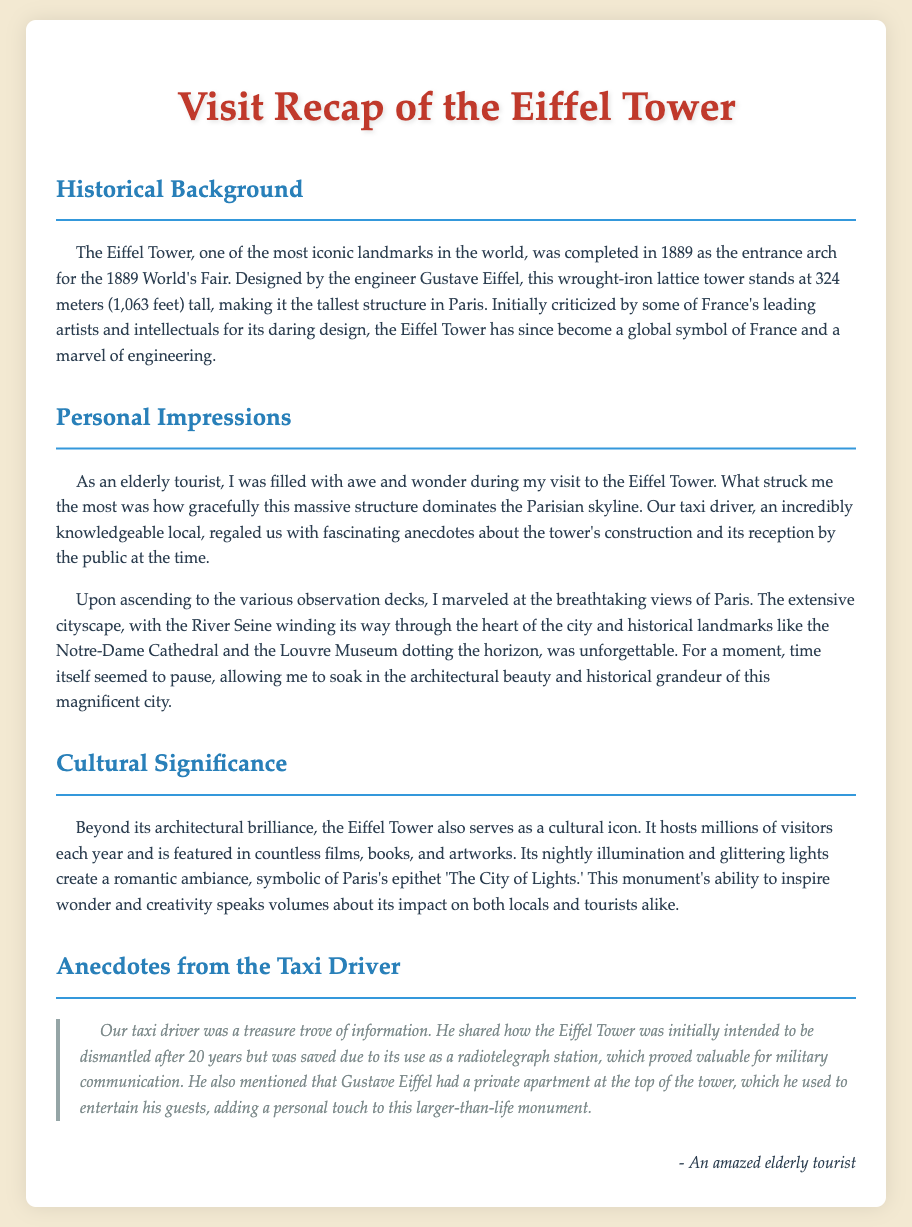What year was the Eiffel Tower completed? The year of completion is mentioned in the historical background section of the document as 1889.
Answer: 1889 Who designed the Eiffel Tower? The document states that the engineer who designed the Eiffel Tower is Gustave Eiffel.
Answer: Gustave Eiffel How tall is the Eiffel Tower in meters? The document specifies that the Eiffel Tower stands at 324 meters tall.
Answer: 324 meters What two historical landmarks can be seen from the Eiffel Tower? The document mentions Notre-Dame Cathedral and the Louvre Museum as landmarks visible from the observation decks.
Answer: Notre-Dame Cathedral and the Louvre Museum Why was the Eiffel Tower initially intended to be dismantled? The taxi driver shared that the Eiffel Tower was initially meant to be dismantled after 20 years.
Answer: After 20 years What use saved the Eiffel Tower from being dismantled? According to the document, the Eiffel Tower’s use as a radiotelegraph station saved it from dismantling.
Answer: Radiotelegraph station What is the Eiffel Tower often referred to as? The document highlights that the Eiffel Tower symbolizes Paris as 'The City of Lights.'
Answer: The City of Lights What type of information did the taxi driver provide? The document emphasizes that the driver was a treasure trove of historical and interesting facts about the Eiffel Tower.
Answer: Historical and interesting facts Where did Gustave Eiffel have a private apartment? The document mentions that Gustave Eiffel had a private apartment at the top of the tower.
Answer: At the top of the tower 